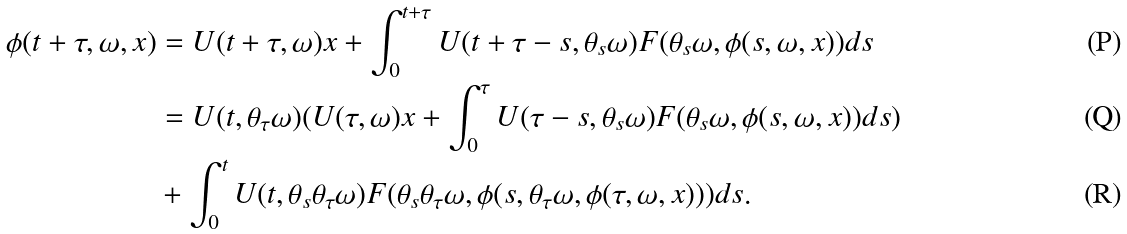Convert formula to latex. <formula><loc_0><loc_0><loc_500><loc_500>\phi ( t + \tau , \omega , x ) & = U ( t + \tau , \omega ) x + \int _ { 0 } ^ { t + \tau } U ( t + \tau - s , \theta _ { s } \omega ) F ( \theta _ { s } \omega , \phi ( s , \omega , x ) ) d s \\ & = U ( t , \theta _ { \tau } \omega ) ( U ( \tau , \omega ) x + \int _ { 0 } ^ { \tau } U ( \tau - s , \theta _ { s } \omega ) F ( \theta _ { s } \omega , \phi ( s , \omega , x ) ) d s ) \\ & + \int _ { 0 } ^ { t } U ( t , \theta _ { s } \theta _ { \tau } \omega ) F ( \theta _ { s } \theta _ { \tau } \omega , \phi ( s , \theta _ { \tau } \omega , \phi ( \tau , \omega , x ) ) ) d s .</formula> 